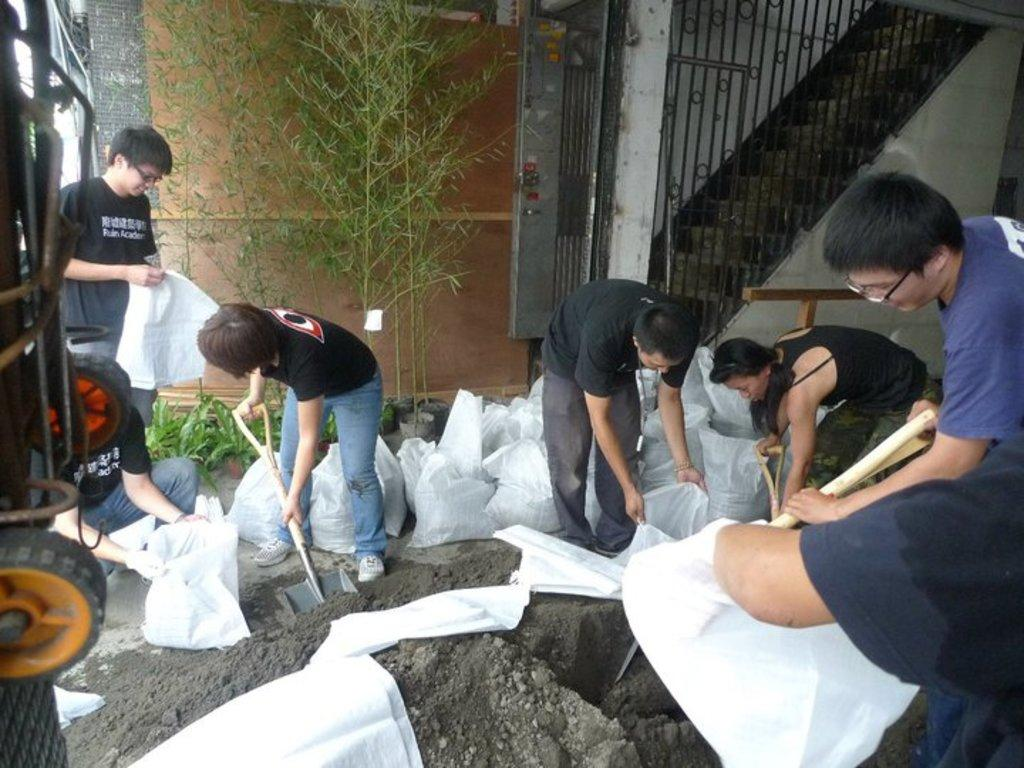What are the persons in the image doing with their hands? The persons in the image are holding objects in their hands. What color are the objects they are holding? The objects they are holding are white. What can be seen in the background of the image? There are trees, a fence, and a staircase in the background. What time of day is depicted in the image, based on the hour? The provided facts do not mention a specific time of day or hour, so it cannot be determined from the image. Can you describe the cloud formation in the image? There is no mention of clouds in the provided facts, so it cannot be determined from the image. 